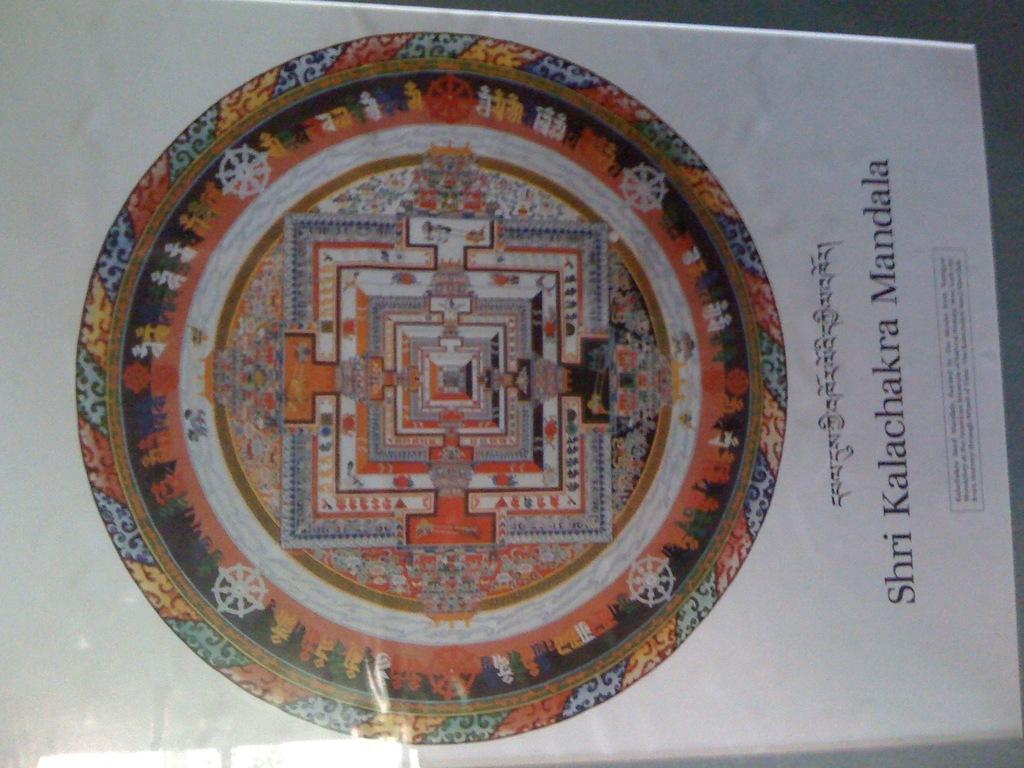How would you summarize this image in a sentence or two? In this picture we can see some information and depiction. It looks like a paper. 